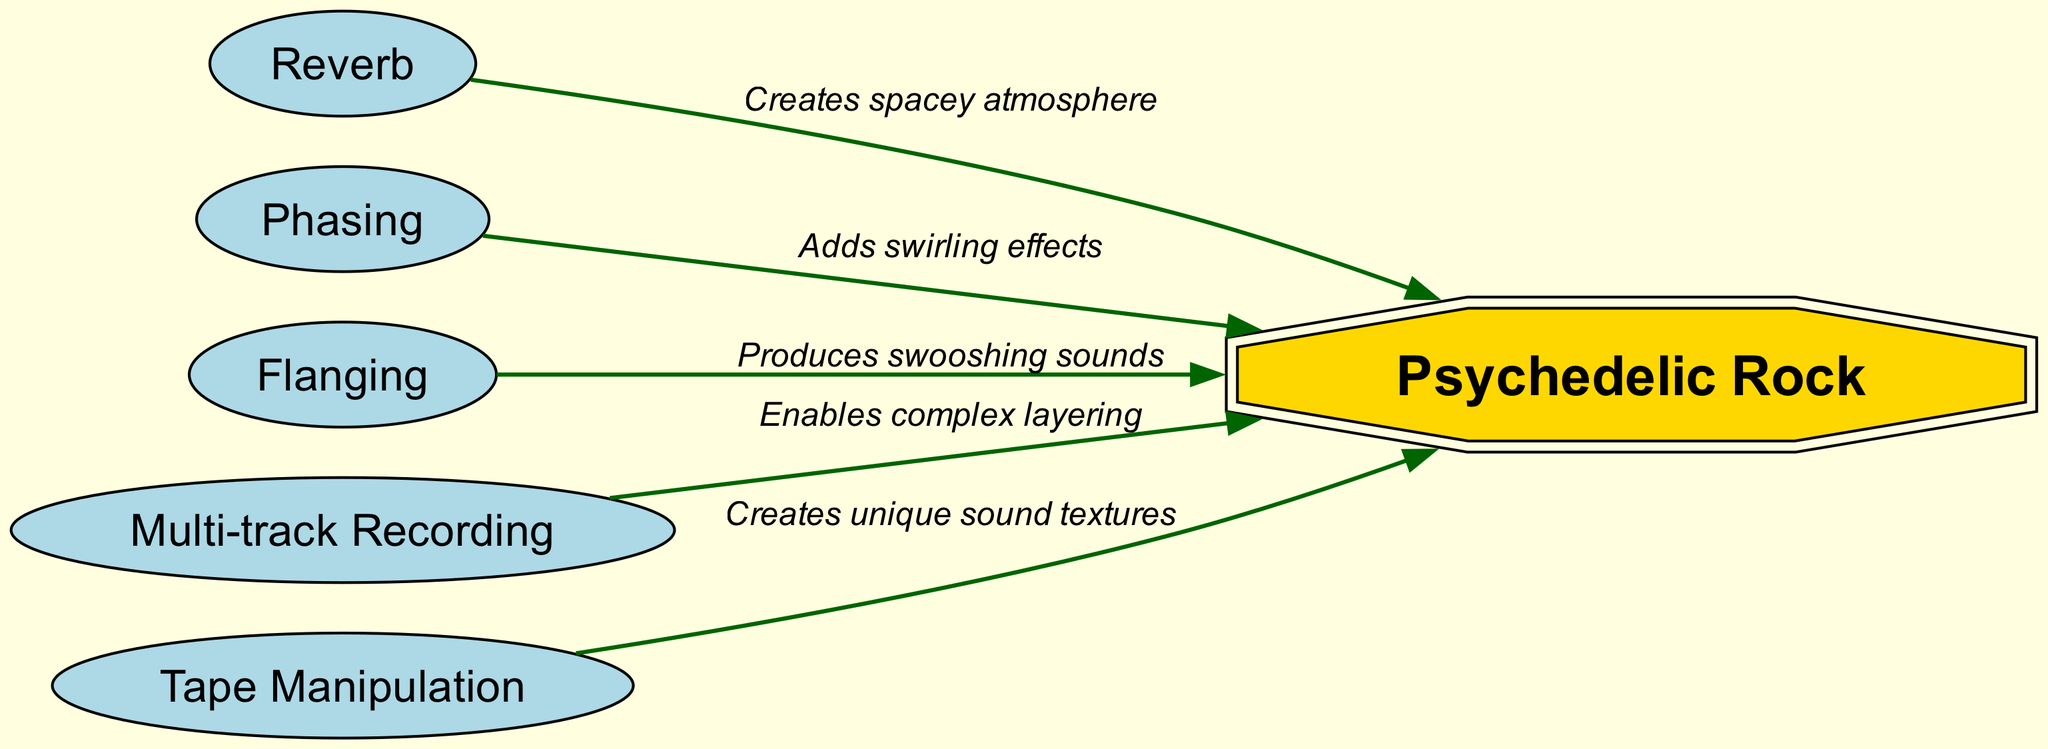What is the central theme of this diagram? The diagram's central theme is represented by the node labeled "Psychedelic Rock." This node is prominently positioned as the target of various studio mixing techniques.
Answer: Psychedelic Rock How many techniques are shown that influence Psychedelic Rock? By counting the edges that stem from the techniques to the "Psychedelic Rock" node, we see there are five distinct techniques highlighted.
Answer: 5 What sound effect does Reverb create for Psychedelic Rock? The edge connecting "Reverb" to "Psychedelic Rock" indicates that Reverb creates a "spacey atmosphere." This specific label describes the effect of the technique on the music genre.
Answer: Spacey atmosphere Which technique is associated with swirling effects? The node "Phasing" is clearly connected to "Psychedelic Rock" with a label stating it "adds swirling effects," making it distinct in its contribution to the genre.
Answer: Phasing How does Multi-track Recording contribute to Psychedelic Rock? The edge from "Multi-track Recording" emphasizes that it "enables complex layering," showcasing its importance in the production of Psychedelic Rock.
Answer: Enables complex layering What unique characteristic does Tape Manipulation offer? Tape Manipulation is linked to Psychedelic Rock with the description that it "creates unique sound textures," indicating its distinct contribution to the genre's sound.
Answer: Creates unique sound textures Which technique produces swooshing sounds? The connection from "Flanging" to "Psychedelic Rock" details that it "produces swooshing sounds," indicating the specific auditory effect it imparts to the music.
Answer: Produces swooshing sounds What type of diagram is used here to depict the relationships? This diagram is a Food Chain type diagram, as it visually represents the influence of various mixing techniques on a central theme.
Answer: Food Chain Which mixing technique leads to the most distinct sound effects for Psychedelic Rock? Evaluating the varying effects mentioned, Tape Manipulation stands out as it creates "unique sound textures," which could be considered the most distinct compared to others.
Answer: Tape Manipulation 